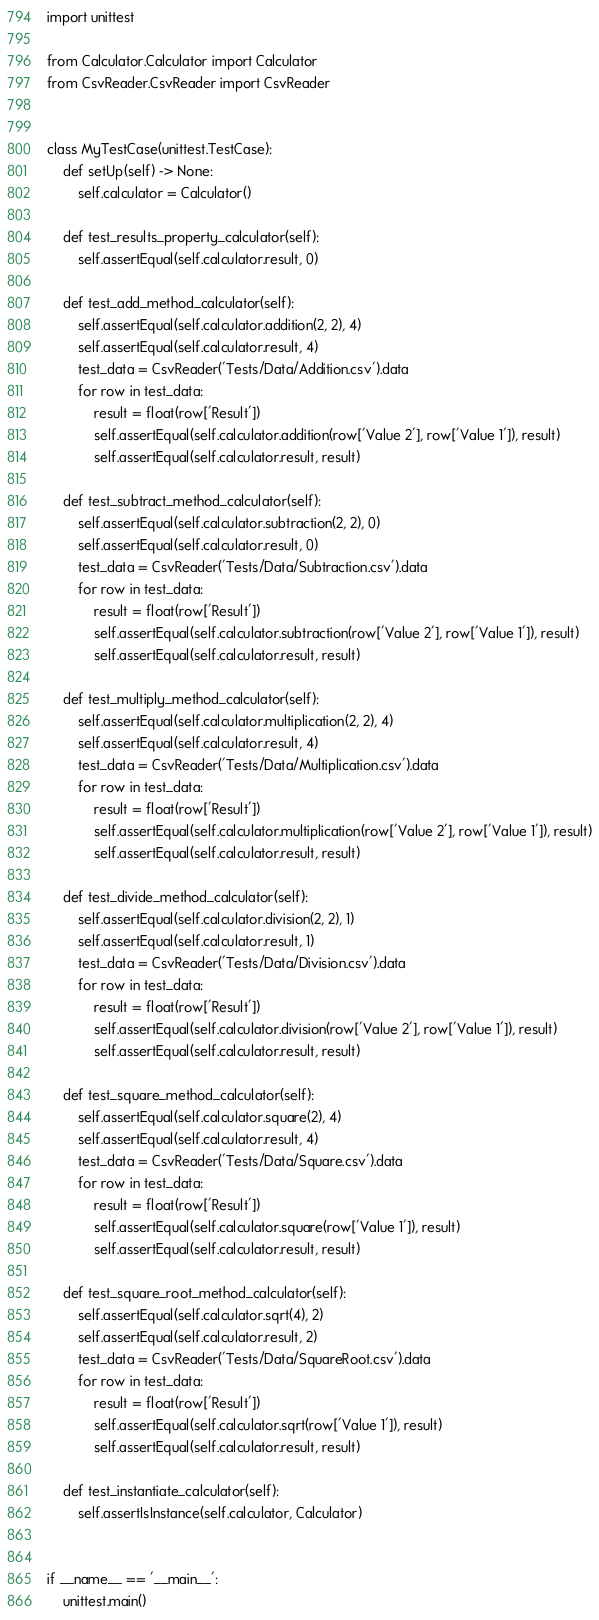<code> <loc_0><loc_0><loc_500><loc_500><_Python_>import unittest

from Calculator.Calculator import Calculator
from CsvReader.CsvReader import CsvReader


class MyTestCase(unittest.TestCase):
    def setUp(self) -> None:
        self.calculator = Calculator()

    def test_results_property_calculator(self):
        self.assertEqual(self.calculator.result, 0)

    def test_add_method_calculator(self):
        self.assertEqual(self.calculator.addition(2, 2), 4)
        self.assertEqual(self.calculator.result, 4)
        test_data = CsvReader('Tests/Data/Addition.csv').data
        for row in test_data:
            result = float(row['Result'])
            self.assertEqual(self.calculator.addition(row['Value 2'], row['Value 1']), result)
            self.assertEqual(self.calculator.result, result)

    def test_subtract_method_calculator(self):
        self.assertEqual(self.calculator.subtraction(2, 2), 0)
        self.assertEqual(self.calculator.result, 0)
        test_data = CsvReader('Tests/Data/Subtraction.csv').data
        for row in test_data:
            result = float(row['Result'])
            self.assertEqual(self.calculator.subtraction(row['Value 2'], row['Value 1']), result)
            self.assertEqual(self.calculator.result, result)

    def test_multiply_method_calculator(self):
        self.assertEqual(self.calculator.multiplication(2, 2), 4)
        self.assertEqual(self.calculator.result, 4)
        test_data = CsvReader('Tests/Data/Multiplication.csv').data
        for row in test_data:
            result = float(row['Result'])
            self.assertEqual(self.calculator.multiplication(row['Value 2'], row['Value 1']), result)
            self.assertEqual(self.calculator.result, result)

    def test_divide_method_calculator(self):
        self.assertEqual(self.calculator.division(2, 2), 1)
        self.assertEqual(self.calculator.result, 1)
        test_data = CsvReader('Tests/Data/Division.csv').data
        for row in test_data:
            result = float(row['Result'])
            self.assertEqual(self.calculator.division(row['Value 2'], row['Value 1']), result)
            self.assertEqual(self.calculator.result, result)

    def test_square_method_calculator(self):
        self.assertEqual(self.calculator.square(2), 4)
        self.assertEqual(self.calculator.result, 4)
        test_data = CsvReader('Tests/Data/Square.csv').data
        for row in test_data:
            result = float(row['Result'])
            self.assertEqual(self.calculator.square(row['Value 1']), result)
            self.assertEqual(self.calculator.result, result)

    def test_square_root_method_calculator(self):
        self.assertEqual(self.calculator.sqrt(4), 2)
        self.assertEqual(self.calculator.result, 2)
        test_data = CsvReader('Tests/Data/SquareRoot.csv').data
        for row in test_data:
            result = float(row['Result'])
            self.assertEqual(self.calculator.sqrt(row['Value 1']), result)
            self.assertEqual(self.calculator.result, result)

    def test_instantiate_calculator(self):
        self.assertIsInstance(self.calculator, Calculator)


if __name__ == '__main__':
    unittest.main()
</code> 